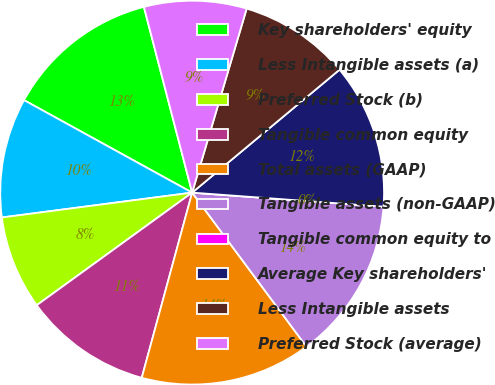<chart> <loc_0><loc_0><loc_500><loc_500><pie_chart><fcel>Key shareholders' equity<fcel>Less Intangible assets (a)<fcel>Preferred Stock (b)<fcel>Tangible common equity<fcel>Total assets (GAAP)<fcel>Tangible assets (non-GAAP)<fcel>Tangible common equity to<fcel>Average Key shareholders'<fcel>Less Intangible assets<fcel>Preferred Stock (average)<nl><fcel>12.95%<fcel>10.07%<fcel>7.91%<fcel>10.79%<fcel>14.39%<fcel>13.67%<fcel>0.0%<fcel>12.23%<fcel>9.35%<fcel>8.63%<nl></chart> 